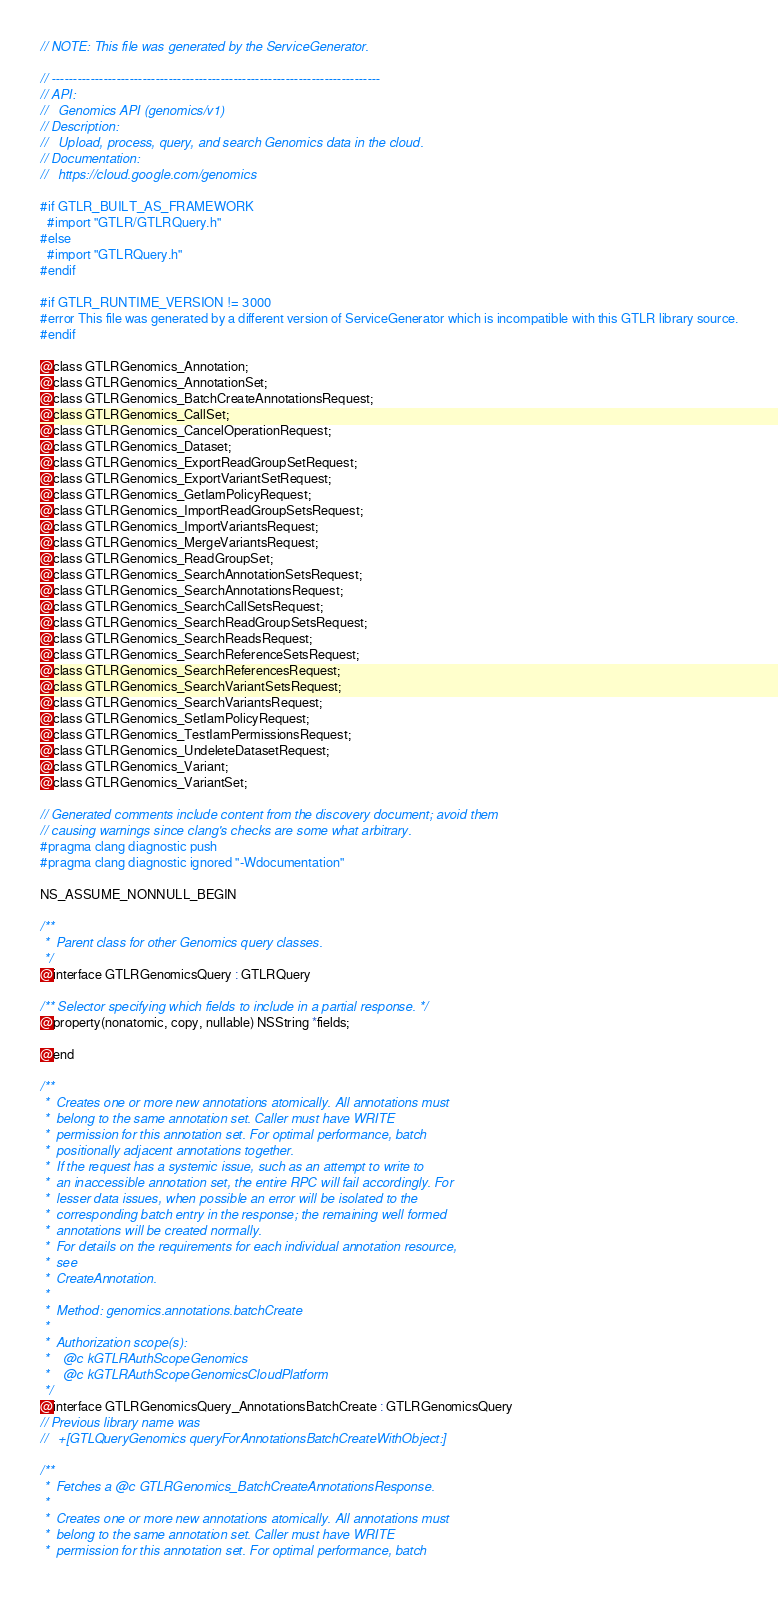<code> <loc_0><loc_0><loc_500><loc_500><_C_>// NOTE: This file was generated by the ServiceGenerator.

// ----------------------------------------------------------------------------
// API:
//   Genomics API (genomics/v1)
// Description:
//   Upload, process, query, and search Genomics data in the cloud.
// Documentation:
//   https://cloud.google.com/genomics

#if GTLR_BUILT_AS_FRAMEWORK
  #import "GTLR/GTLRQuery.h"
#else
  #import "GTLRQuery.h"
#endif

#if GTLR_RUNTIME_VERSION != 3000
#error This file was generated by a different version of ServiceGenerator which is incompatible with this GTLR library source.
#endif

@class GTLRGenomics_Annotation;
@class GTLRGenomics_AnnotationSet;
@class GTLRGenomics_BatchCreateAnnotationsRequest;
@class GTLRGenomics_CallSet;
@class GTLRGenomics_CancelOperationRequest;
@class GTLRGenomics_Dataset;
@class GTLRGenomics_ExportReadGroupSetRequest;
@class GTLRGenomics_ExportVariantSetRequest;
@class GTLRGenomics_GetIamPolicyRequest;
@class GTLRGenomics_ImportReadGroupSetsRequest;
@class GTLRGenomics_ImportVariantsRequest;
@class GTLRGenomics_MergeVariantsRequest;
@class GTLRGenomics_ReadGroupSet;
@class GTLRGenomics_SearchAnnotationSetsRequest;
@class GTLRGenomics_SearchAnnotationsRequest;
@class GTLRGenomics_SearchCallSetsRequest;
@class GTLRGenomics_SearchReadGroupSetsRequest;
@class GTLRGenomics_SearchReadsRequest;
@class GTLRGenomics_SearchReferenceSetsRequest;
@class GTLRGenomics_SearchReferencesRequest;
@class GTLRGenomics_SearchVariantSetsRequest;
@class GTLRGenomics_SearchVariantsRequest;
@class GTLRGenomics_SetIamPolicyRequest;
@class GTLRGenomics_TestIamPermissionsRequest;
@class GTLRGenomics_UndeleteDatasetRequest;
@class GTLRGenomics_Variant;
@class GTLRGenomics_VariantSet;

// Generated comments include content from the discovery document; avoid them
// causing warnings since clang's checks are some what arbitrary.
#pragma clang diagnostic push
#pragma clang diagnostic ignored "-Wdocumentation"

NS_ASSUME_NONNULL_BEGIN

/**
 *  Parent class for other Genomics query classes.
 */
@interface GTLRGenomicsQuery : GTLRQuery

/** Selector specifying which fields to include in a partial response. */
@property(nonatomic, copy, nullable) NSString *fields;

@end

/**
 *  Creates one or more new annotations atomically. All annotations must
 *  belong to the same annotation set. Caller must have WRITE
 *  permission for this annotation set. For optimal performance, batch
 *  positionally adjacent annotations together.
 *  If the request has a systemic issue, such as an attempt to write to
 *  an inaccessible annotation set, the entire RPC will fail accordingly. For
 *  lesser data issues, when possible an error will be isolated to the
 *  corresponding batch entry in the response; the remaining well formed
 *  annotations will be created normally.
 *  For details on the requirements for each individual annotation resource,
 *  see
 *  CreateAnnotation.
 *
 *  Method: genomics.annotations.batchCreate
 *
 *  Authorization scope(s):
 *    @c kGTLRAuthScopeGenomics
 *    @c kGTLRAuthScopeGenomicsCloudPlatform
 */
@interface GTLRGenomicsQuery_AnnotationsBatchCreate : GTLRGenomicsQuery
// Previous library name was
//   +[GTLQueryGenomics queryForAnnotationsBatchCreateWithObject:]

/**
 *  Fetches a @c GTLRGenomics_BatchCreateAnnotationsResponse.
 *
 *  Creates one or more new annotations atomically. All annotations must
 *  belong to the same annotation set. Caller must have WRITE
 *  permission for this annotation set. For optimal performance, batch</code> 